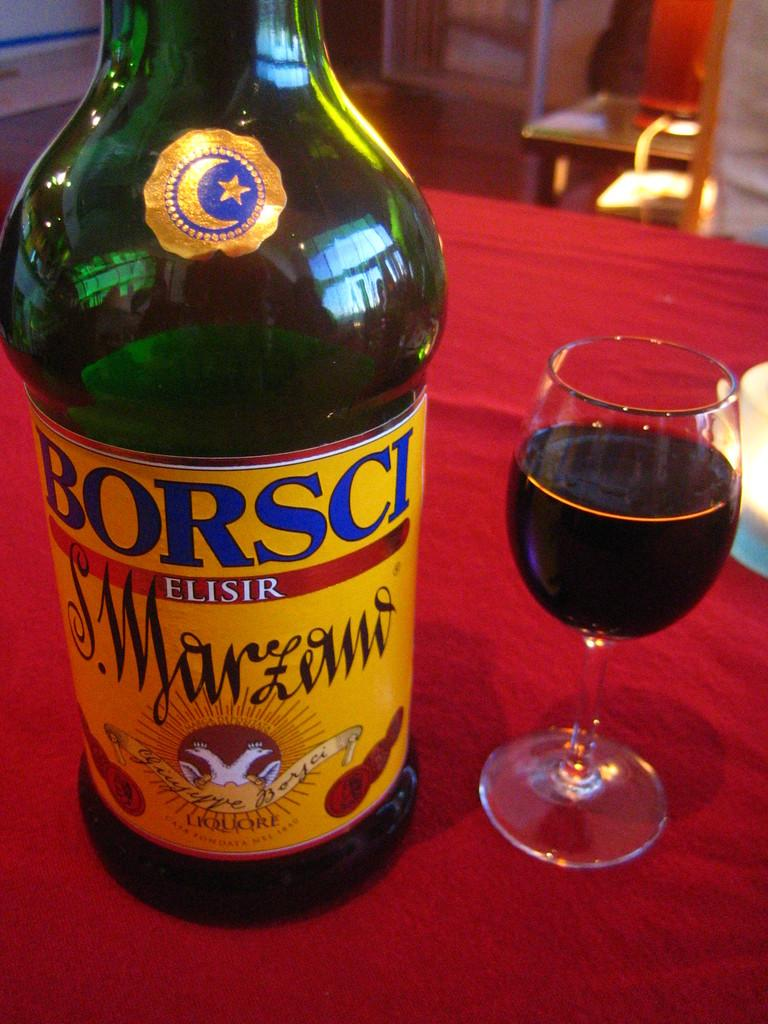<image>
Provide a brief description of the given image. A glass of wine and a bottle called Borsci Elisir. 